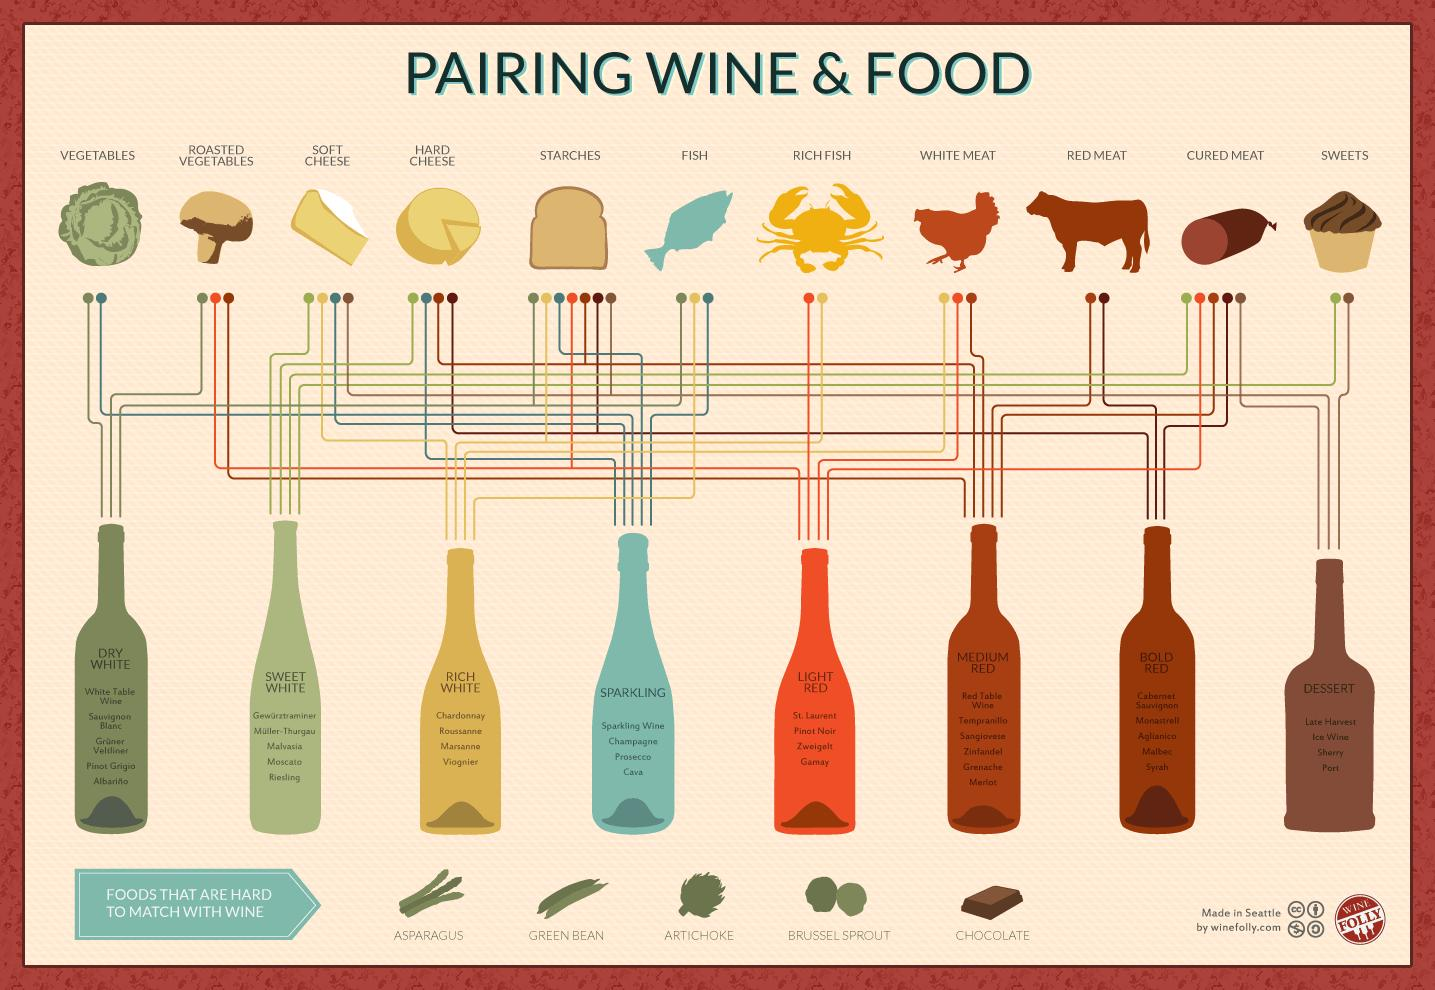Draw attention to some important aspects in this diagram. Pinot Noir falls under the category of light red wine. It can be challenging to find a wine that pairs well with certain types of chocolate due to their distinct flavors and textures. 